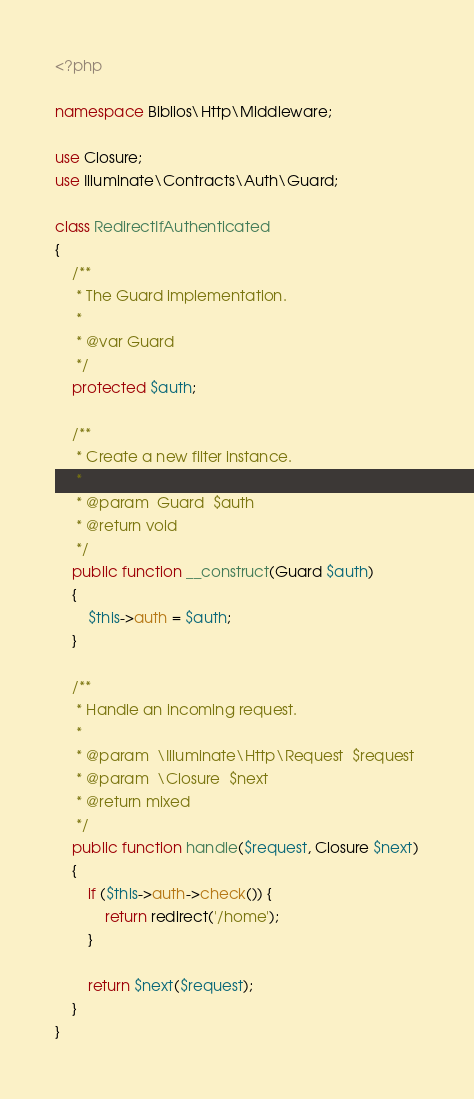<code> <loc_0><loc_0><loc_500><loc_500><_PHP_><?php

namespace Biblios\Http\Middleware;

use Closure;
use Illuminate\Contracts\Auth\Guard;

class RedirectIfAuthenticated
{
    /**
     * The Guard implementation.
     *
     * @var Guard
     */
    protected $auth;

    /**
     * Create a new filter instance.
     *
     * @param  Guard  $auth
     * @return void
     */
    public function __construct(Guard $auth)
    {
        $this->auth = $auth;
    }

    /**
     * Handle an incoming request.
     *
     * @param  \Illuminate\Http\Request  $request
     * @param  \Closure  $next
     * @return mixed
     */
    public function handle($request, Closure $next)
    {
        if ($this->auth->check()) {
            return redirect('/home');
        }

        return $next($request);
    }
}
</code> 